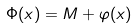<formula> <loc_0><loc_0><loc_500><loc_500>\Phi ( x ) = M + \varphi ( x )</formula> 